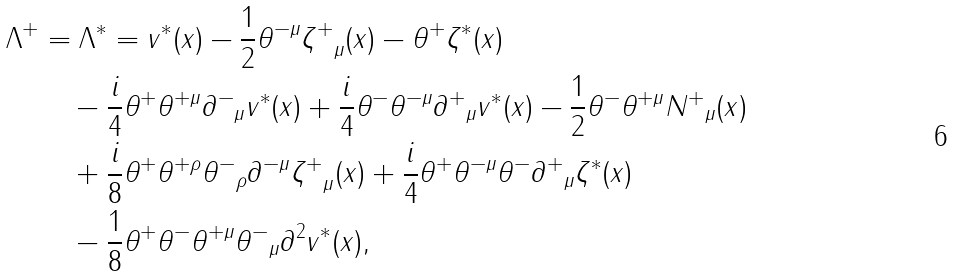Convert formula to latex. <formula><loc_0><loc_0><loc_500><loc_500>\Lambda ^ { + } & = \Lambda ^ { * } = v ^ { * } ( x ) - \frac { 1 } { 2 } \theta ^ { - \mu } { \zeta ^ { + } } _ { \mu } ( x ) - \theta ^ { + } \zeta ^ { * } ( x ) \\ & \quad - \frac { i } { 4 } \theta ^ { + } \theta ^ { + \mu } { \partial ^ { - } } _ { \mu } v ^ { * } ( x ) + \frac { i } { 4 } \theta ^ { - } \theta ^ { - \mu } { \partial ^ { + } } _ { \mu } v ^ { * } ( x ) - \frac { 1 } { 2 } \theta ^ { - } \theta ^ { + \mu } { N ^ { + } } _ { \mu } ( x ) \\ & \quad + \frac { i } { 8 } \theta ^ { + } \theta ^ { + \rho } { \theta ^ { - } } _ { \rho } { \partial ^ { - \mu } } { \zeta ^ { + } } _ { \mu } ( x ) + \frac { i } { 4 } \theta ^ { + } \theta ^ { - \mu } \theta ^ { - } { \partial ^ { + } } _ { \mu } \zeta ^ { * } ( x ) \\ & \quad - \frac { 1 } { 8 } \theta ^ { + } \theta ^ { - } \theta ^ { + \mu } { \theta ^ { - } } _ { \mu } \partial ^ { 2 } v ^ { * } ( x ) ,</formula> 